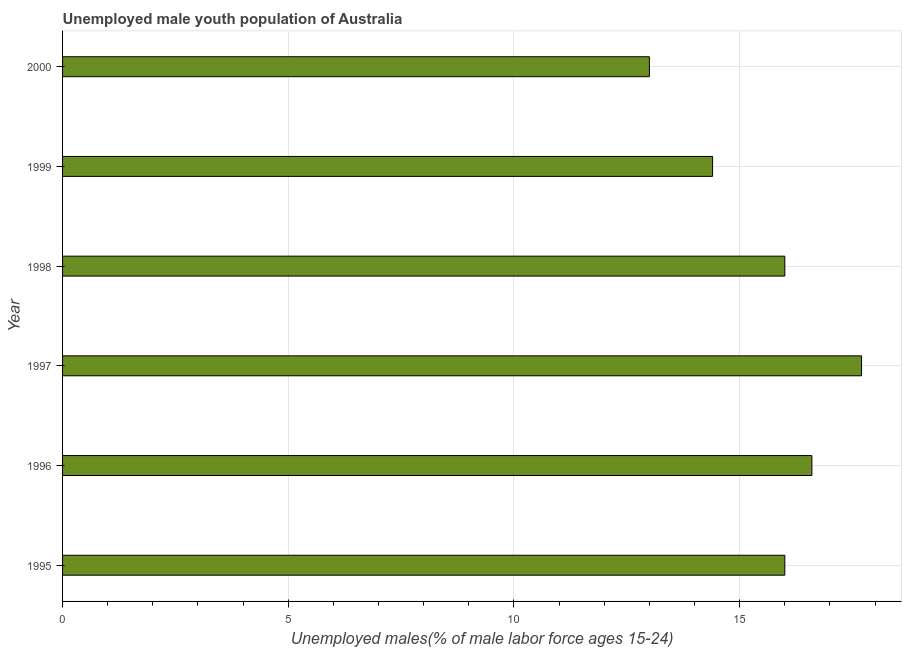Does the graph contain any zero values?
Ensure brevity in your answer.  No. What is the title of the graph?
Your answer should be compact. Unemployed male youth population of Australia. What is the label or title of the X-axis?
Keep it short and to the point. Unemployed males(% of male labor force ages 15-24). What is the label or title of the Y-axis?
Your answer should be compact. Year. What is the unemployed male youth in 1998?
Offer a very short reply. 16. Across all years, what is the maximum unemployed male youth?
Offer a terse response. 17.7. Across all years, what is the minimum unemployed male youth?
Provide a succinct answer. 13. In which year was the unemployed male youth minimum?
Your answer should be compact. 2000. What is the sum of the unemployed male youth?
Provide a short and direct response. 93.7. What is the difference between the unemployed male youth in 1998 and 2000?
Give a very brief answer. 3. What is the average unemployed male youth per year?
Offer a very short reply. 15.62. What is the median unemployed male youth?
Offer a very short reply. 16. What is the ratio of the unemployed male youth in 1996 to that in 1998?
Ensure brevity in your answer.  1.04. Is the difference between the unemployed male youth in 1995 and 1997 greater than the difference between any two years?
Provide a short and direct response. No. Is the sum of the unemployed male youth in 1995 and 1996 greater than the maximum unemployed male youth across all years?
Offer a very short reply. Yes. How many bars are there?
Make the answer very short. 6. How many years are there in the graph?
Ensure brevity in your answer.  6. What is the difference between two consecutive major ticks on the X-axis?
Give a very brief answer. 5. What is the Unemployed males(% of male labor force ages 15-24) in 1996?
Ensure brevity in your answer.  16.6. What is the Unemployed males(% of male labor force ages 15-24) of 1997?
Your answer should be very brief. 17.7. What is the Unemployed males(% of male labor force ages 15-24) in 1998?
Offer a very short reply. 16. What is the Unemployed males(% of male labor force ages 15-24) in 1999?
Provide a short and direct response. 14.4. What is the Unemployed males(% of male labor force ages 15-24) in 2000?
Provide a short and direct response. 13. What is the difference between the Unemployed males(% of male labor force ages 15-24) in 1995 and 1996?
Offer a very short reply. -0.6. What is the difference between the Unemployed males(% of male labor force ages 15-24) in 1995 and 1998?
Offer a terse response. 0. What is the difference between the Unemployed males(% of male labor force ages 15-24) in 1995 and 1999?
Your answer should be compact. 1.6. What is the difference between the Unemployed males(% of male labor force ages 15-24) in 1996 and 1997?
Your answer should be compact. -1.1. What is the difference between the Unemployed males(% of male labor force ages 15-24) in 1996 and 1999?
Your response must be concise. 2.2. What is the difference between the Unemployed males(% of male labor force ages 15-24) in 1996 and 2000?
Provide a succinct answer. 3.6. What is the difference between the Unemployed males(% of male labor force ages 15-24) in 1998 and 1999?
Make the answer very short. 1.6. What is the difference between the Unemployed males(% of male labor force ages 15-24) in 1998 and 2000?
Keep it short and to the point. 3. What is the difference between the Unemployed males(% of male labor force ages 15-24) in 1999 and 2000?
Your response must be concise. 1.4. What is the ratio of the Unemployed males(% of male labor force ages 15-24) in 1995 to that in 1997?
Give a very brief answer. 0.9. What is the ratio of the Unemployed males(% of male labor force ages 15-24) in 1995 to that in 1998?
Your response must be concise. 1. What is the ratio of the Unemployed males(% of male labor force ages 15-24) in 1995 to that in 1999?
Your answer should be very brief. 1.11. What is the ratio of the Unemployed males(% of male labor force ages 15-24) in 1995 to that in 2000?
Ensure brevity in your answer.  1.23. What is the ratio of the Unemployed males(% of male labor force ages 15-24) in 1996 to that in 1997?
Your answer should be very brief. 0.94. What is the ratio of the Unemployed males(% of male labor force ages 15-24) in 1996 to that in 1998?
Your response must be concise. 1.04. What is the ratio of the Unemployed males(% of male labor force ages 15-24) in 1996 to that in 1999?
Ensure brevity in your answer.  1.15. What is the ratio of the Unemployed males(% of male labor force ages 15-24) in 1996 to that in 2000?
Ensure brevity in your answer.  1.28. What is the ratio of the Unemployed males(% of male labor force ages 15-24) in 1997 to that in 1998?
Ensure brevity in your answer.  1.11. What is the ratio of the Unemployed males(% of male labor force ages 15-24) in 1997 to that in 1999?
Ensure brevity in your answer.  1.23. What is the ratio of the Unemployed males(% of male labor force ages 15-24) in 1997 to that in 2000?
Your answer should be compact. 1.36. What is the ratio of the Unemployed males(% of male labor force ages 15-24) in 1998 to that in 1999?
Give a very brief answer. 1.11. What is the ratio of the Unemployed males(% of male labor force ages 15-24) in 1998 to that in 2000?
Provide a succinct answer. 1.23. What is the ratio of the Unemployed males(% of male labor force ages 15-24) in 1999 to that in 2000?
Make the answer very short. 1.11. 